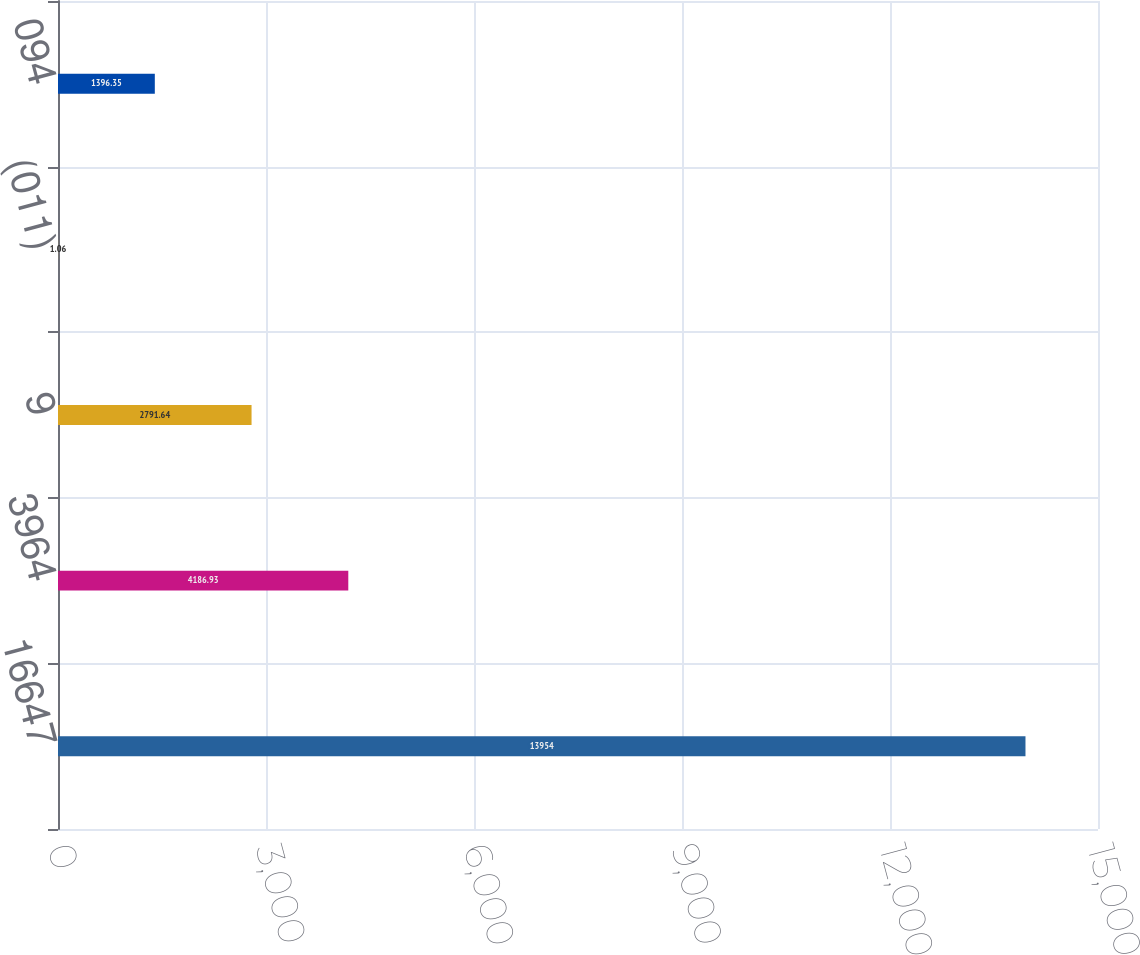Convert chart. <chart><loc_0><loc_0><loc_500><loc_500><bar_chart><fcel>16647<fcel>3964<fcel>9<fcel>(011)<fcel>094<nl><fcel>13954<fcel>4186.93<fcel>2791.64<fcel>1.06<fcel>1396.35<nl></chart> 